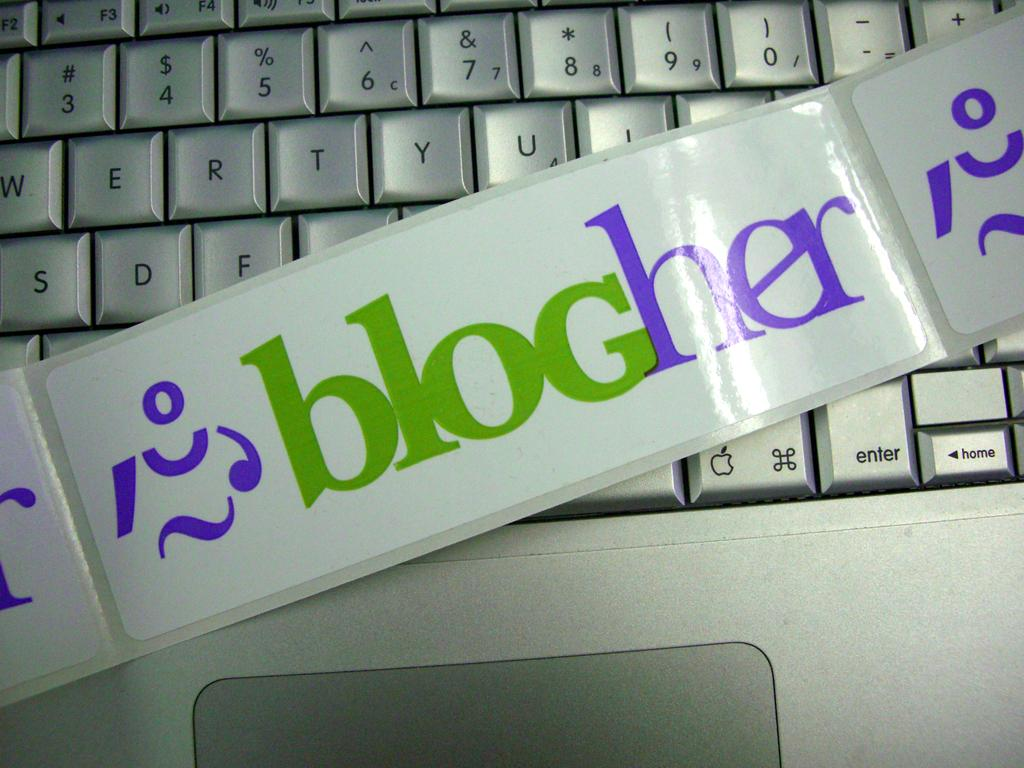<image>
Offer a succinct explanation of the picture presented. Sticker saying "Blogher" on top of a keyboard. 